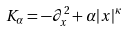Convert formula to latex. <formula><loc_0><loc_0><loc_500><loc_500>K _ { \alpha } = - \partial _ { x } ^ { 2 } + \alpha | x | ^ { \kappa }</formula> 